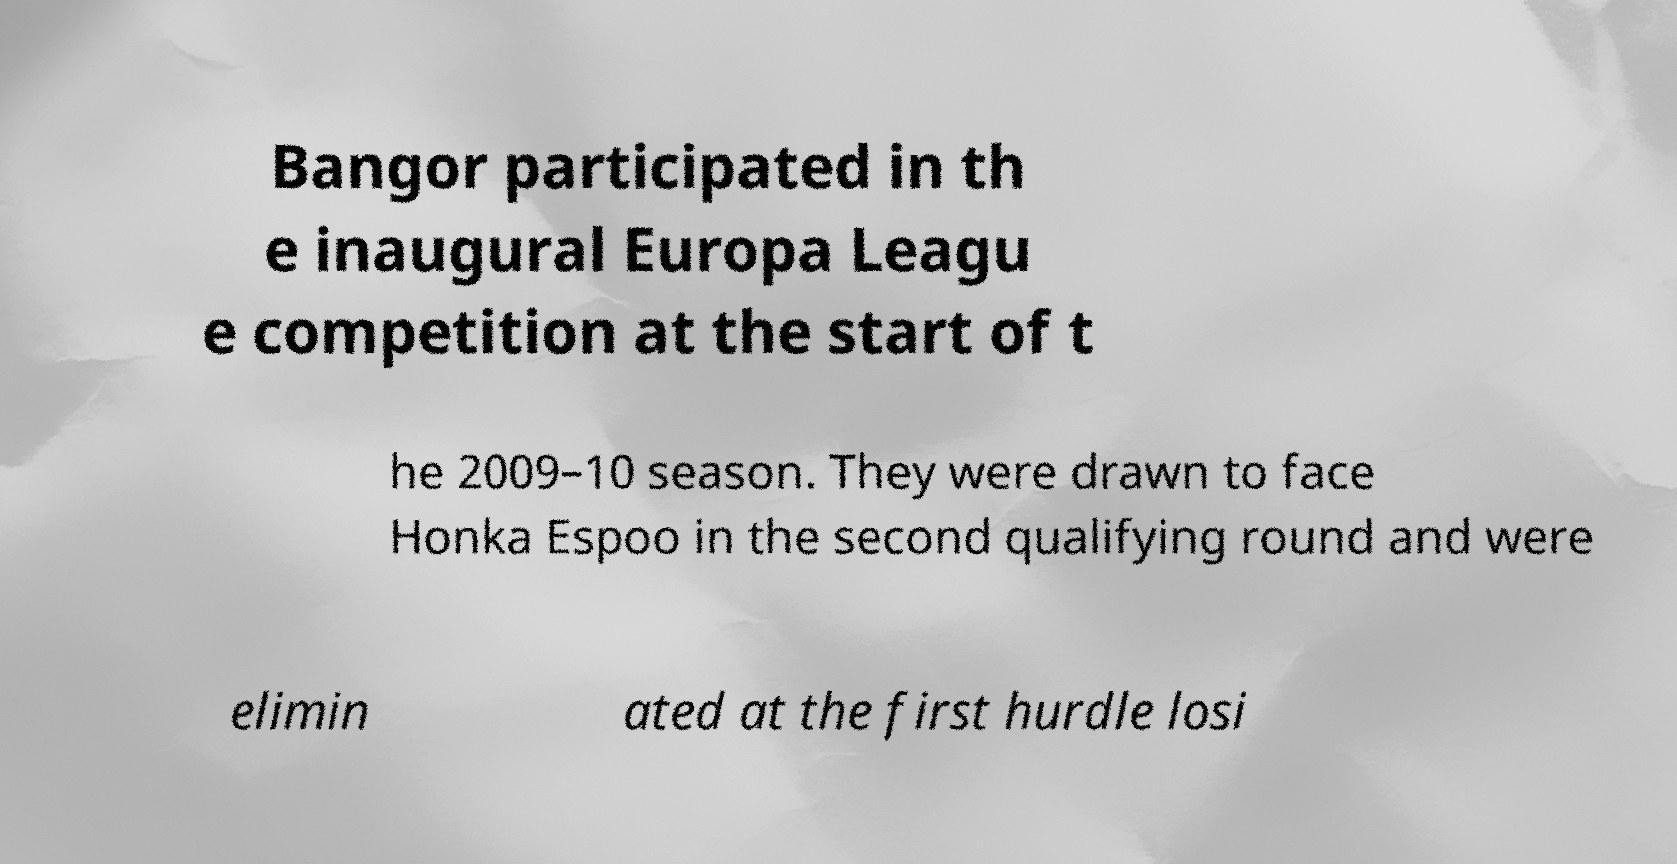Can you read and provide the text displayed in the image?This photo seems to have some interesting text. Can you extract and type it out for me? Bangor participated in th e inaugural Europa Leagu e competition at the start of t he 2009–10 season. They were drawn to face Honka Espoo in the second qualifying round and were elimin ated at the first hurdle losi 